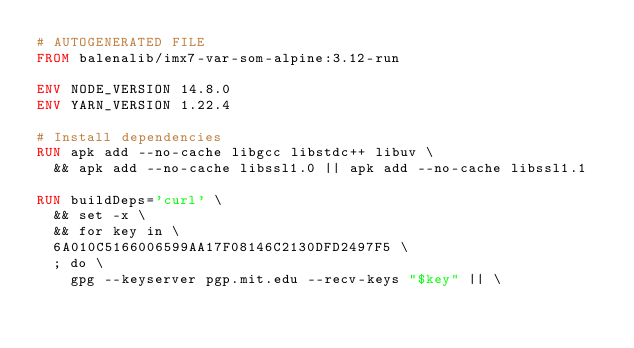<code> <loc_0><loc_0><loc_500><loc_500><_Dockerfile_># AUTOGENERATED FILE
FROM balenalib/imx7-var-som-alpine:3.12-run

ENV NODE_VERSION 14.8.0
ENV YARN_VERSION 1.22.4

# Install dependencies
RUN apk add --no-cache libgcc libstdc++ libuv \
	&& apk add --no-cache libssl1.0 || apk add --no-cache libssl1.1

RUN buildDeps='curl' \
	&& set -x \
	&& for key in \
	6A010C5166006599AA17F08146C2130DFD2497F5 \
	; do \
		gpg --keyserver pgp.mit.edu --recv-keys "$key" || \</code> 